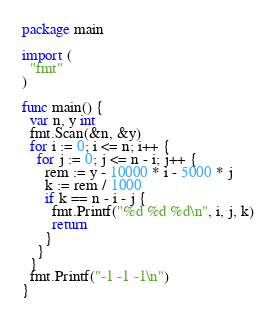Convert code to text. <code><loc_0><loc_0><loc_500><loc_500><_Go_>package main

import (
  "fmt"
)

func main() {
  var n, y int
  fmt.Scan(&n, &y)
  for i := 0; i <= n; i++ {
    for j := 0; j <= n - i; j++ {
      rem := y - 10000 * i - 5000 * j
      k := rem / 1000
      if k == n - i - j {
        fmt.Printf("%d %d %d\n", i, j, k)
        return
      }
    }
  }
  fmt.Printf("-1 -1 -1\n")
}
</code> 